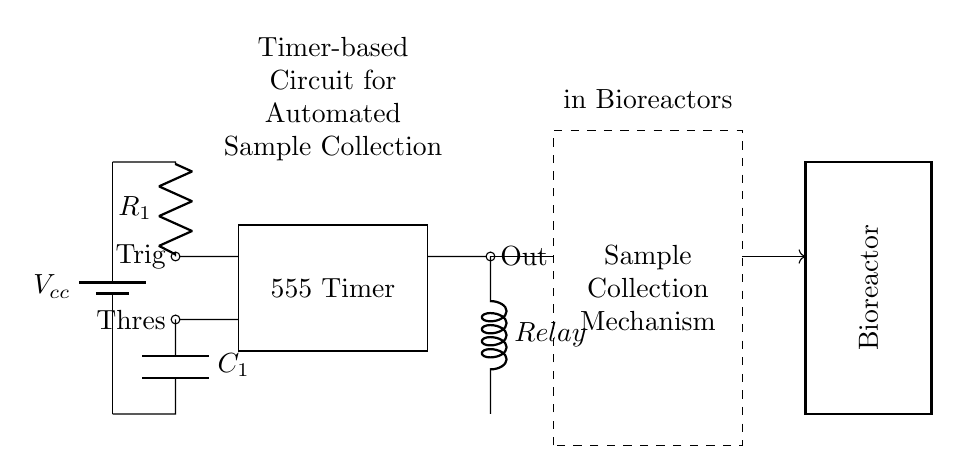What is the power supply voltage in the circuit? The power supply voltage is indicated by the label Vcc connected to the battery symbol in the diagram. It represents the voltage supplied to the timer and other components.
Answer: Vcc What does the 555 timer control in this circuit? The 555 timer controls the timing mechanism for triggering the relay. It receives input signals and provides an output to activate the sample collection mechanism at set intervals.
Answer: Relay How many resistors are in the circuit? The circuit contains one resistor labeled R1, which is part of the RC timing network connected to the 555 timer, used for timing purposes.
Answer: One What is the function of the capacitor in this circuit? The capacitor, labeled C1, is used in conjunction with the resistor R1 to create a timing interval for the 555 timer. It helps determine the duration for which the relay will activate for sample collection.
Answer: Timing What type of relay is used in the circuit? The relay is labeled as a 'cute inductor,' which indicates that it is a type of electrical switch that is operated by an electromagnetic coil and can control the sample collection mechanism.
Answer: Relay How is the sample collection mechanism activated? The sample collection mechanism is activated when the timer's output signal triggers the relay, allowing the flow of current to the collection device at predefined intervals set by the RC timing network.
Answer: Timer output 